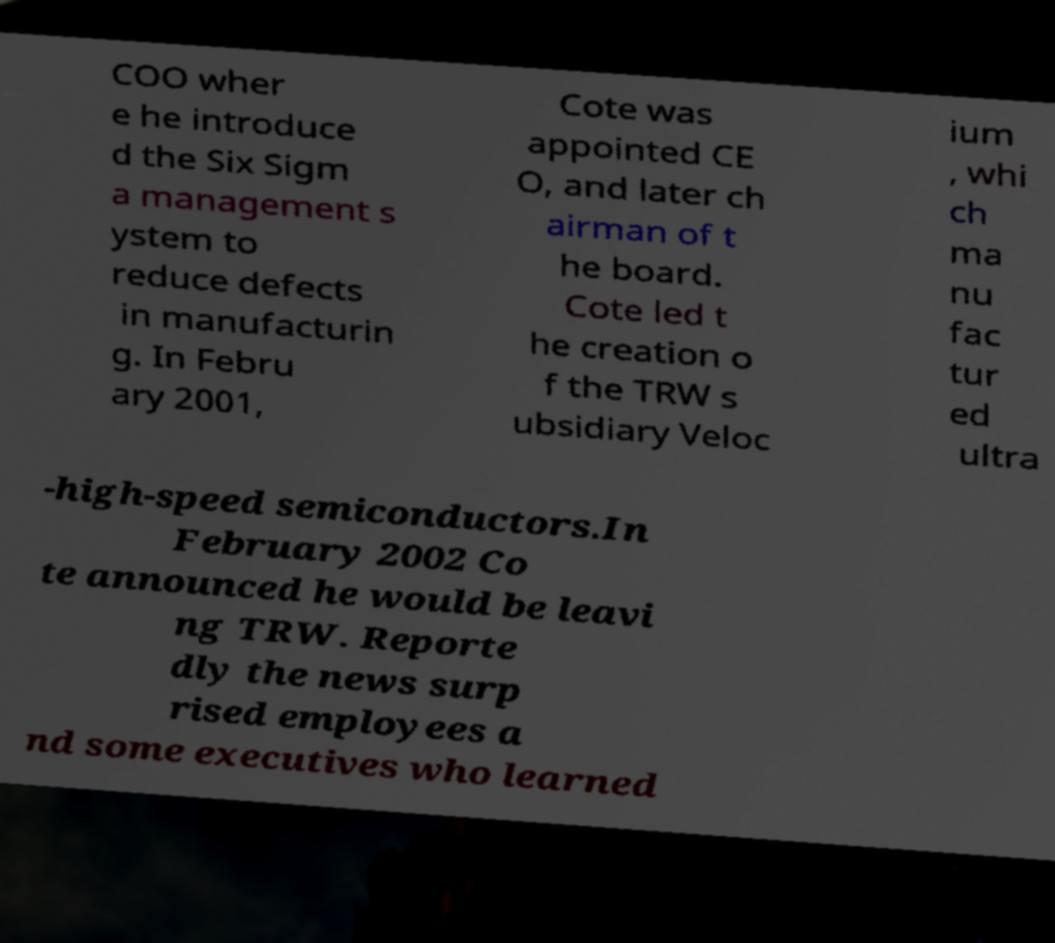Can you accurately transcribe the text from the provided image for me? COO wher e he introduce d the Six Sigm a management s ystem to reduce defects in manufacturin g. In Febru ary 2001, Cote was appointed CE O, and later ch airman of t he board. Cote led t he creation o f the TRW s ubsidiary Veloc ium , whi ch ma nu fac tur ed ultra -high-speed semiconductors.In February 2002 Co te announced he would be leavi ng TRW. Reporte dly the news surp rised employees a nd some executives who learned 